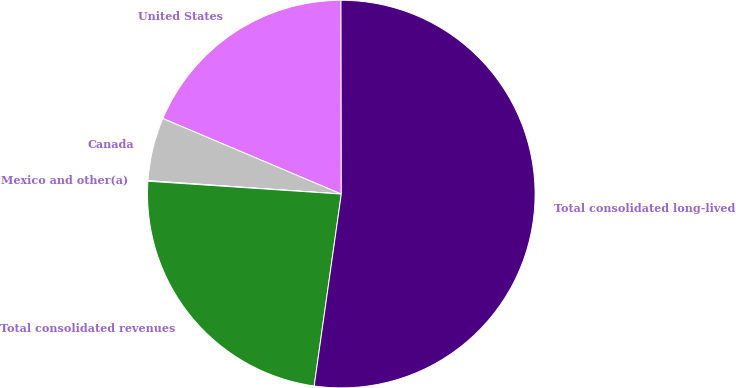Convert chart to OTSL. <chart><loc_0><loc_0><loc_500><loc_500><pie_chart><fcel>United States<fcel>Canada<fcel>Mexico and other(a)<fcel>Total consolidated revenues<fcel>Total consolidated long-lived<nl><fcel>18.6%<fcel>5.27%<fcel>0.05%<fcel>23.82%<fcel>52.26%<nl></chart> 